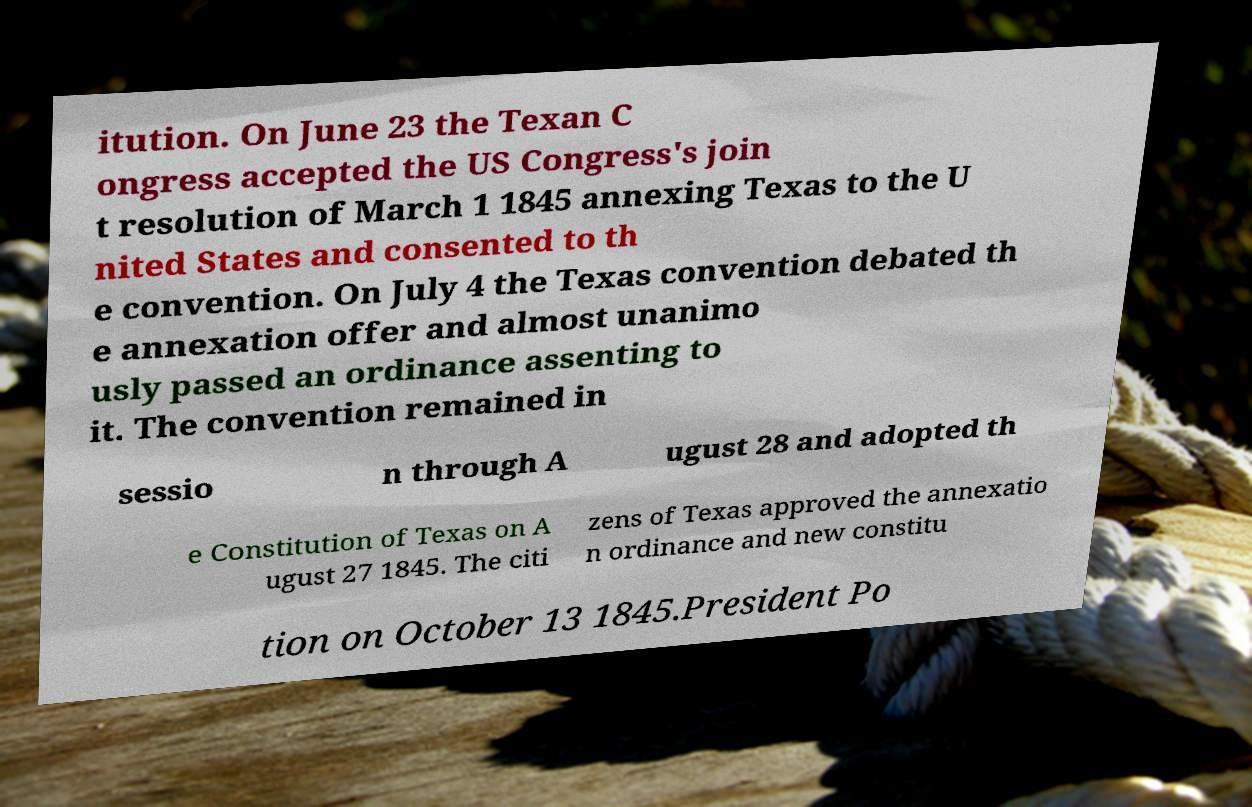Please read and relay the text visible in this image. What does it say? itution. On June 23 the Texan C ongress accepted the US Congress's join t resolution of March 1 1845 annexing Texas to the U nited States and consented to th e convention. On July 4 the Texas convention debated th e annexation offer and almost unanimo usly passed an ordinance assenting to it. The convention remained in sessio n through A ugust 28 and adopted th e Constitution of Texas on A ugust 27 1845. The citi zens of Texas approved the annexatio n ordinance and new constitu tion on October 13 1845.President Po 